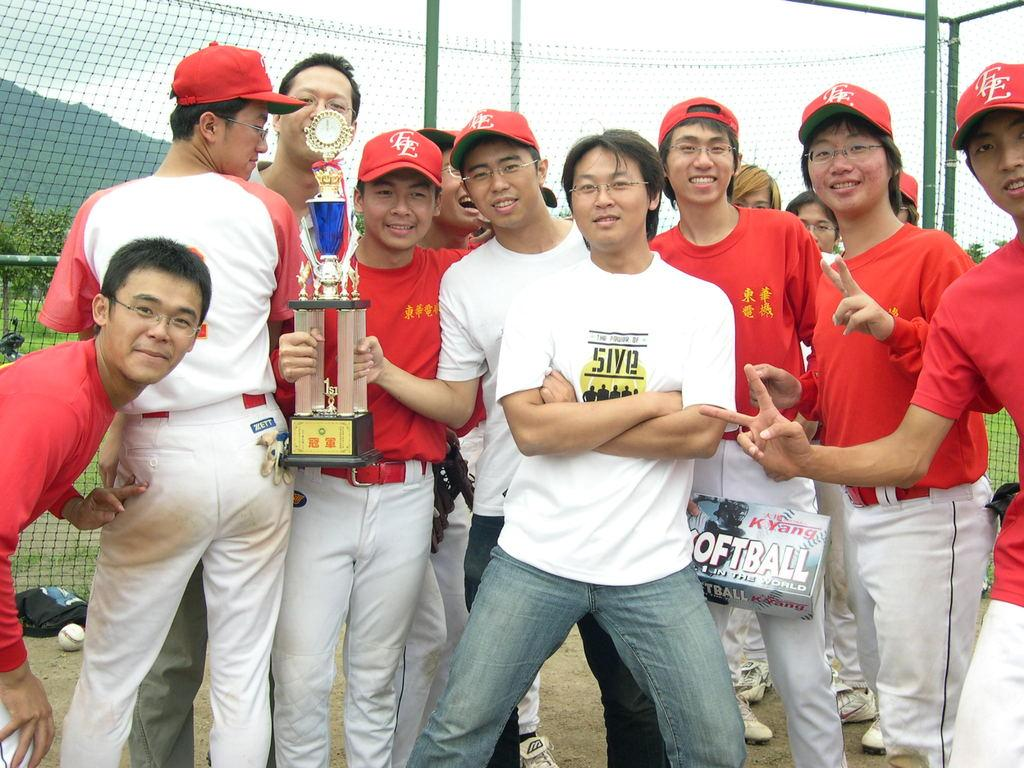<image>
Create a compact narrative representing the image presented. a man is wearing a shirt that says five as he stands next to friends 